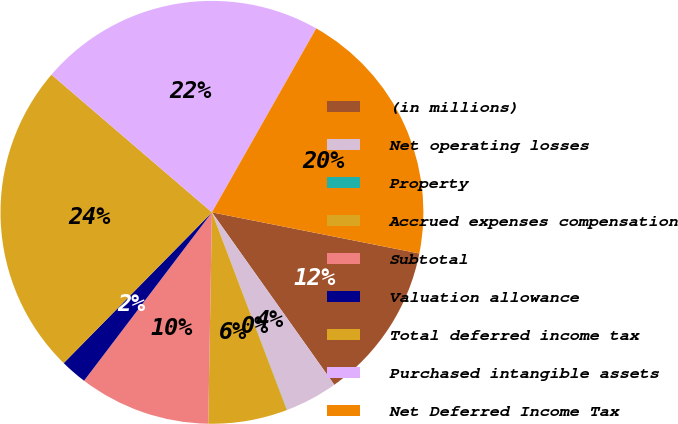Convert chart. <chart><loc_0><loc_0><loc_500><loc_500><pie_chart><fcel>(in millions)<fcel>Net operating losses<fcel>Property<fcel>Accrued expenses compensation<fcel>Subtotal<fcel>Valuation allowance<fcel>Total deferred income tax<fcel>Purchased intangible assets<fcel>Net Deferred Income Tax<nl><fcel>12.06%<fcel>4.04%<fcel>0.02%<fcel>6.04%<fcel>10.06%<fcel>2.03%<fcel>23.92%<fcel>21.92%<fcel>19.91%<nl></chart> 